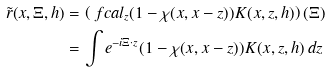<formula> <loc_0><loc_0><loc_500><loc_500>\tilde { r } ( x , \Xi , h ) & = \left ( \ f c a l _ { z } ( 1 - \chi ( x , x - z ) ) K ( x , z , h ) \right ) ( \Xi ) \\ & = \int e ^ { - i \Xi \cdot z } ( 1 - \chi ( x , x - z ) ) K ( x , z , h ) \, d z</formula> 